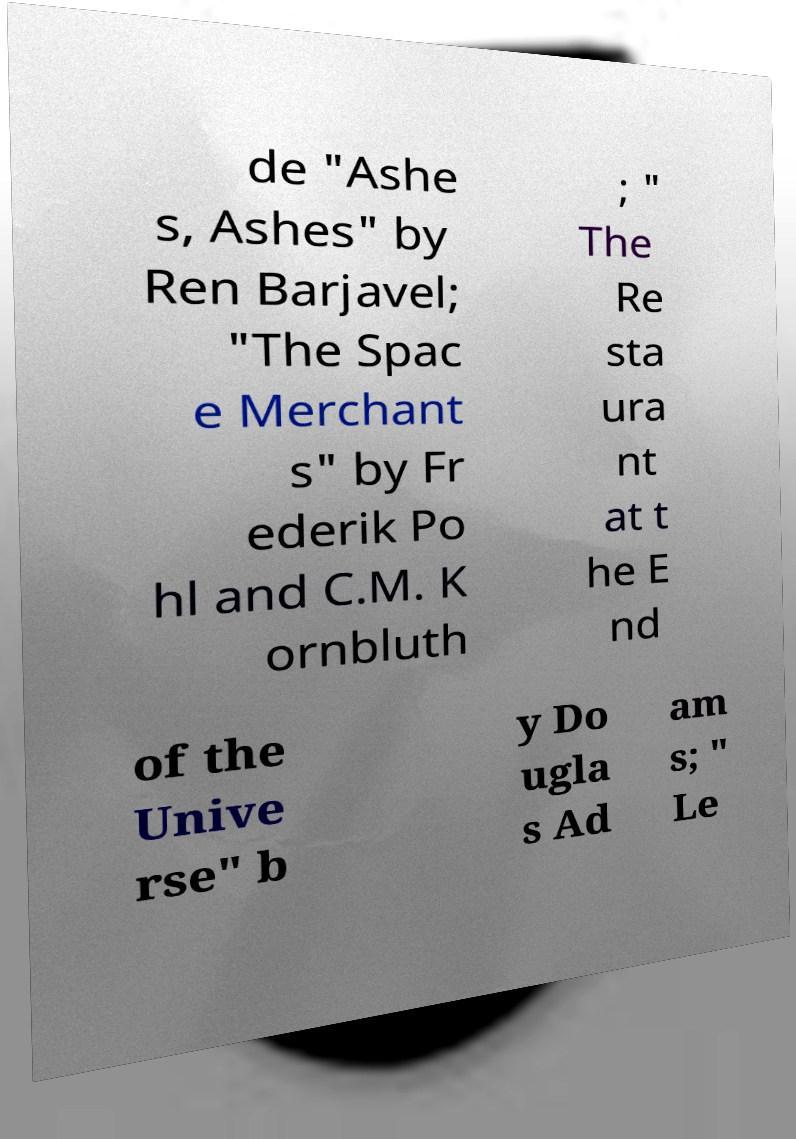I need the written content from this picture converted into text. Can you do that? de "Ashe s, Ashes" by Ren Barjavel; "The Spac e Merchant s" by Fr ederik Po hl and C.M. K ornbluth ; " The Re sta ura nt at t he E nd of the Unive rse" b y Do ugla s Ad am s; " Le 